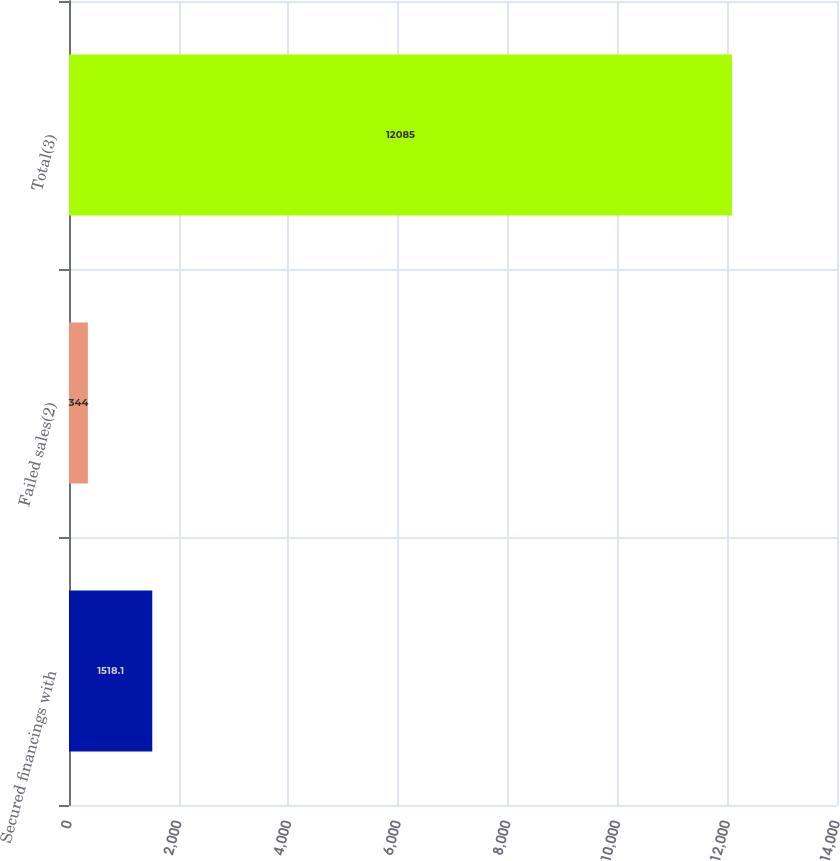Convert chart. <chart><loc_0><loc_0><loc_500><loc_500><bar_chart><fcel>Secured financings with<fcel>Failed sales(2)<fcel>Total(3)<nl><fcel>1518.1<fcel>344<fcel>12085<nl></chart> 